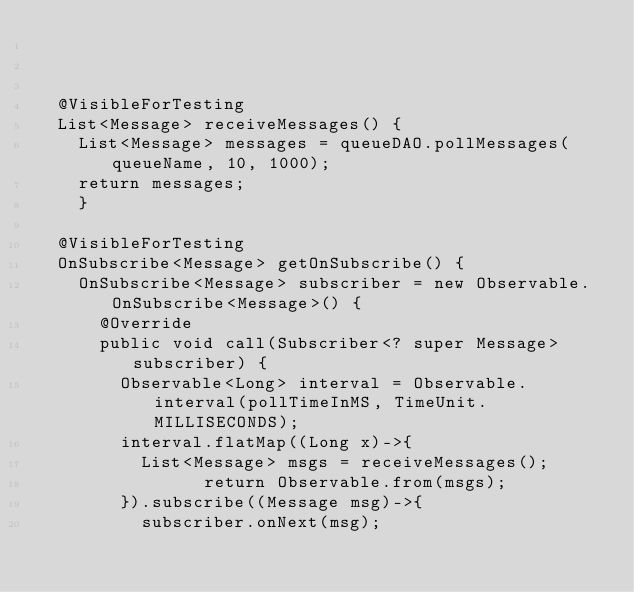Convert code to text. <code><loc_0><loc_0><loc_500><loc_500><_Java_>	
	
	
	@VisibleForTesting
	List<Message> receiveMessages() {
		List<Message> messages = queueDAO.pollMessages(queueName, 10, 1000);
		return messages;
    }
	
	@VisibleForTesting
	OnSubscribe<Message> getOnSubscribe() {
		OnSubscribe<Message> subscriber = new Observable.OnSubscribe<Message>() {
			@Override
			public void call(Subscriber<? super Message> subscriber) {
				Observable<Long> interval = Observable.interval(pollTimeInMS, TimeUnit.MILLISECONDS);		
				interval.flatMap((Long x)->{
					List<Message> msgs = receiveMessages();
		            return Observable.from(msgs);
				}).subscribe((Message msg)->{
					subscriber.onNext(msg);</code> 